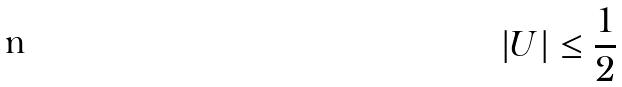<formula> <loc_0><loc_0><loc_500><loc_500>| U | \leq \frac { 1 } { 2 }</formula> 